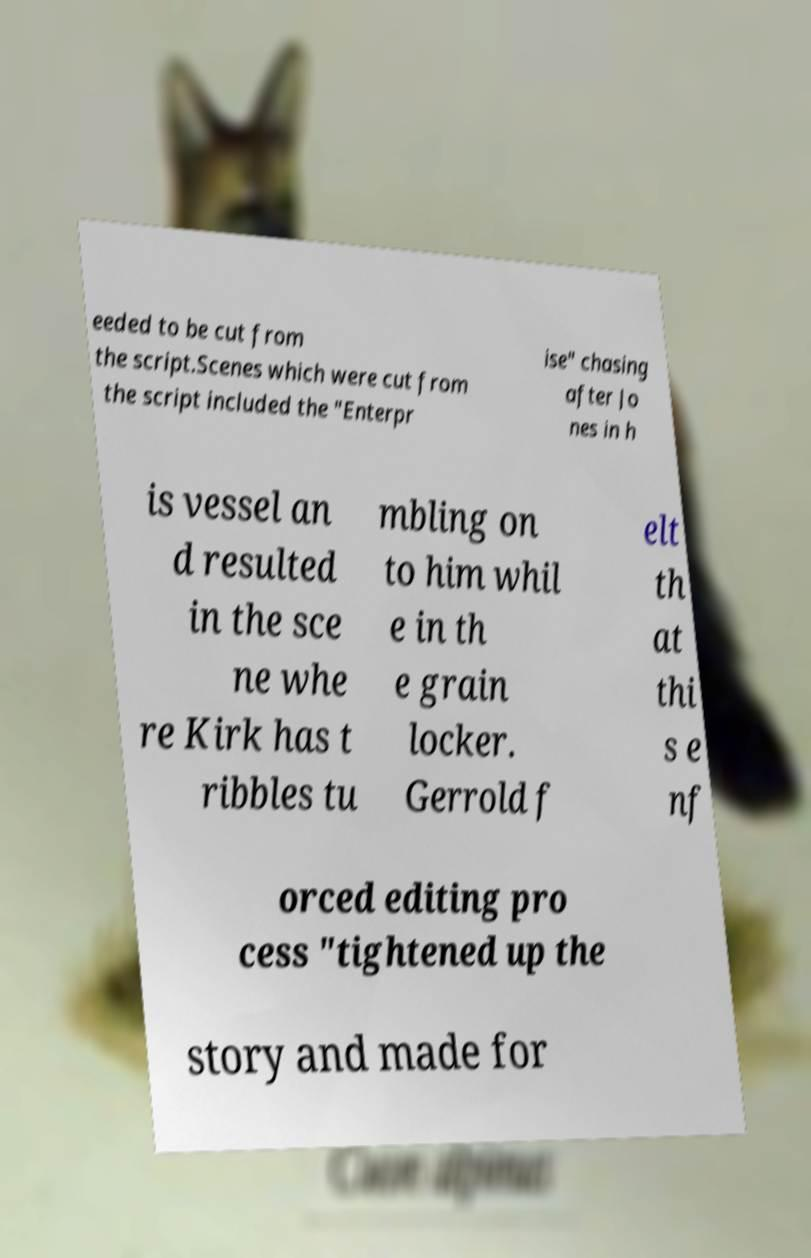Could you extract and type out the text from this image? eeded to be cut from the script.Scenes which were cut from the script included the "Enterpr ise" chasing after Jo nes in h is vessel an d resulted in the sce ne whe re Kirk has t ribbles tu mbling on to him whil e in th e grain locker. Gerrold f elt th at thi s e nf orced editing pro cess "tightened up the story and made for 